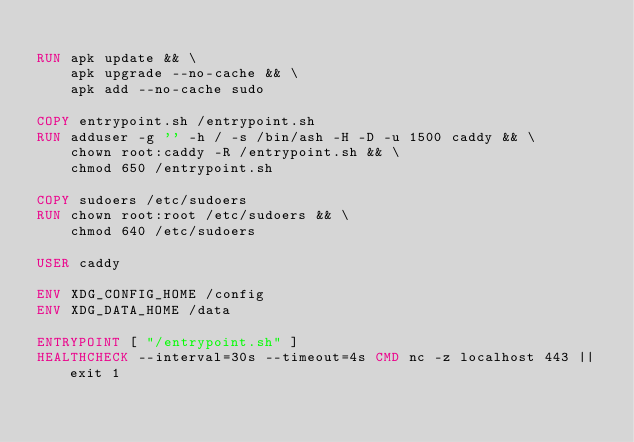<code> <loc_0><loc_0><loc_500><loc_500><_Dockerfile_>
RUN apk update && \
    apk upgrade --no-cache && \
    apk add --no-cache sudo

COPY entrypoint.sh /entrypoint.sh
RUN adduser -g '' -h / -s /bin/ash -H -D -u 1500 caddy && \
    chown root:caddy -R /entrypoint.sh && \
    chmod 650 /entrypoint.sh

COPY sudoers /etc/sudoers
RUN chown root:root /etc/sudoers && \
    chmod 640 /etc/sudoers

USER caddy

ENV XDG_CONFIG_HOME /config
ENV XDG_DATA_HOME /data

ENTRYPOINT [ "/entrypoint.sh" ]
HEALTHCHECK --interval=30s --timeout=4s CMD nc -z localhost 443 || exit 1
</code> 